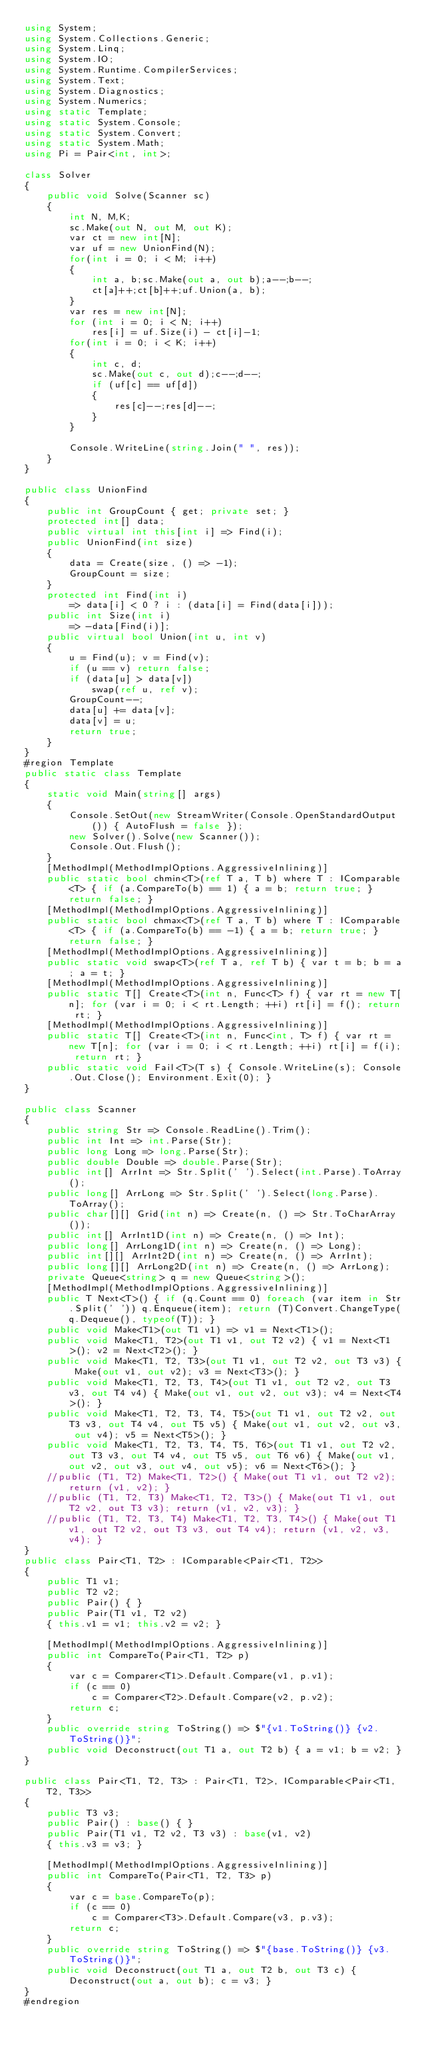Convert code to text. <code><loc_0><loc_0><loc_500><loc_500><_C#_>using System;
using System.Collections.Generic;
using System.Linq;
using System.IO;
using System.Runtime.CompilerServices;
using System.Text;
using System.Diagnostics;
using System.Numerics;
using static Template;
using static System.Console;
using static System.Convert;
using static System.Math;
using Pi = Pair<int, int>;

class Solver
{
    public void Solve(Scanner sc)
    {
        int N, M,K;
        sc.Make(out N, out M, out K);
        var ct = new int[N];
        var uf = new UnionFind(N);
        for(int i = 0; i < M; i++)
        {
            int a, b;sc.Make(out a, out b);a--;b--;
            ct[a]++;ct[b]++;uf.Union(a, b);
        }
        var res = new int[N];
        for (int i = 0; i < N; i++)
            res[i] = uf.Size(i) - ct[i]-1;
        for(int i = 0; i < K; i++)
        {
            int c, d;
            sc.Make(out c, out d);c--;d--;
            if (uf[c] == uf[d])
            {
                res[c]--;res[d]--;
            }
        }

        Console.WriteLine(string.Join(" ", res));
    }
}

public class UnionFind
{
    public int GroupCount { get; private set; }
    protected int[] data;
    public virtual int this[int i] => Find(i);
    public UnionFind(int size)
    {
        data = Create(size, () => -1);
        GroupCount = size;
    }
    protected int Find(int i)
        => data[i] < 0 ? i : (data[i] = Find(data[i]));
    public int Size(int i)
        => -data[Find(i)];
    public virtual bool Union(int u, int v)
    {
        u = Find(u); v = Find(v);
        if (u == v) return false;
        if (data[u] > data[v])
            swap(ref u, ref v);
        GroupCount--;
        data[u] += data[v];
        data[v] = u;
        return true;
    }
}
#region Template
public static class Template
{
    static void Main(string[] args)
    {
        Console.SetOut(new StreamWriter(Console.OpenStandardOutput()) { AutoFlush = false });
        new Solver().Solve(new Scanner());
        Console.Out.Flush();
    }
    [MethodImpl(MethodImplOptions.AggressiveInlining)]
    public static bool chmin<T>(ref T a, T b) where T : IComparable<T> { if (a.CompareTo(b) == 1) { a = b; return true; } return false; }
    [MethodImpl(MethodImplOptions.AggressiveInlining)]
    public static bool chmax<T>(ref T a, T b) where T : IComparable<T> { if (a.CompareTo(b) == -1) { a = b; return true; } return false; }
    [MethodImpl(MethodImplOptions.AggressiveInlining)]
    public static void swap<T>(ref T a, ref T b) { var t = b; b = a; a = t; }
    [MethodImpl(MethodImplOptions.AggressiveInlining)]
    public static T[] Create<T>(int n, Func<T> f) { var rt = new T[n]; for (var i = 0; i < rt.Length; ++i) rt[i] = f(); return rt; }
    [MethodImpl(MethodImplOptions.AggressiveInlining)]
    public static T[] Create<T>(int n, Func<int, T> f) { var rt = new T[n]; for (var i = 0; i < rt.Length; ++i) rt[i] = f(i); return rt; }
    public static void Fail<T>(T s) { Console.WriteLine(s); Console.Out.Close(); Environment.Exit(0); }
}

public class Scanner
{
    public string Str => Console.ReadLine().Trim();
    public int Int => int.Parse(Str);
    public long Long => long.Parse(Str);
    public double Double => double.Parse(Str);
    public int[] ArrInt => Str.Split(' ').Select(int.Parse).ToArray();
    public long[] ArrLong => Str.Split(' ').Select(long.Parse).ToArray();
    public char[][] Grid(int n) => Create(n, () => Str.ToCharArray());
    public int[] ArrInt1D(int n) => Create(n, () => Int);
    public long[] ArrLong1D(int n) => Create(n, () => Long);
    public int[][] ArrInt2D(int n) => Create(n, () => ArrInt);
    public long[][] ArrLong2D(int n) => Create(n, () => ArrLong);
    private Queue<string> q = new Queue<string>();
    [MethodImpl(MethodImplOptions.AggressiveInlining)]
    public T Next<T>() { if (q.Count == 0) foreach (var item in Str.Split(' ')) q.Enqueue(item); return (T)Convert.ChangeType(q.Dequeue(), typeof(T)); }
    public void Make<T1>(out T1 v1) => v1 = Next<T1>();
    public void Make<T1, T2>(out T1 v1, out T2 v2) { v1 = Next<T1>(); v2 = Next<T2>(); }
    public void Make<T1, T2, T3>(out T1 v1, out T2 v2, out T3 v3) { Make(out v1, out v2); v3 = Next<T3>(); }
    public void Make<T1, T2, T3, T4>(out T1 v1, out T2 v2, out T3 v3, out T4 v4) { Make(out v1, out v2, out v3); v4 = Next<T4>(); }
    public void Make<T1, T2, T3, T4, T5>(out T1 v1, out T2 v2, out T3 v3, out T4 v4, out T5 v5) { Make(out v1, out v2, out v3, out v4); v5 = Next<T5>(); }
    public void Make<T1, T2, T3, T4, T5, T6>(out T1 v1, out T2 v2, out T3 v3, out T4 v4, out T5 v5, out T6 v6) { Make(out v1, out v2, out v3, out v4, out v5); v6 = Next<T6>(); }
    //public (T1, T2) Make<T1, T2>() { Make(out T1 v1, out T2 v2); return (v1, v2); }
    //public (T1, T2, T3) Make<T1, T2, T3>() { Make(out T1 v1, out T2 v2, out T3 v3); return (v1, v2, v3); }
    //public (T1, T2, T3, T4) Make<T1, T2, T3, T4>() { Make(out T1 v1, out T2 v2, out T3 v3, out T4 v4); return (v1, v2, v3, v4); }
}
public class Pair<T1, T2> : IComparable<Pair<T1, T2>>
{
    public T1 v1;
    public T2 v2;
    public Pair() { }
    public Pair(T1 v1, T2 v2)
    { this.v1 = v1; this.v2 = v2; }

    [MethodImpl(MethodImplOptions.AggressiveInlining)]
    public int CompareTo(Pair<T1, T2> p)
    {
        var c = Comparer<T1>.Default.Compare(v1, p.v1);
        if (c == 0)
            c = Comparer<T2>.Default.Compare(v2, p.v2);
        return c;
    }
    public override string ToString() => $"{v1.ToString()} {v2.ToString()}";
    public void Deconstruct(out T1 a, out T2 b) { a = v1; b = v2; }
}

public class Pair<T1, T2, T3> : Pair<T1, T2>, IComparable<Pair<T1, T2, T3>>
{
    public T3 v3;
    public Pair() : base() { }
    public Pair(T1 v1, T2 v2, T3 v3) : base(v1, v2)
    { this.v3 = v3; }

    [MethodImpl(MethodImplOptions.AggressiveInlining)]
    public int CompareTo(Pair<T1, T2, T3> p)
    {
        var c = base.CompareTo(p);
        if (c == 0)
            c = Comparer<T3>.Default.Compare(v3, p.v3);
        return c;
    }
    public override string ToString() => $"{base.ToString()} {v3.ToString()}";
    public void Deconstruct(out T1 a, out T2 b, out T3 c) { Deconstruct(out a, out b); c = v3; }
}
#endregion</code> 